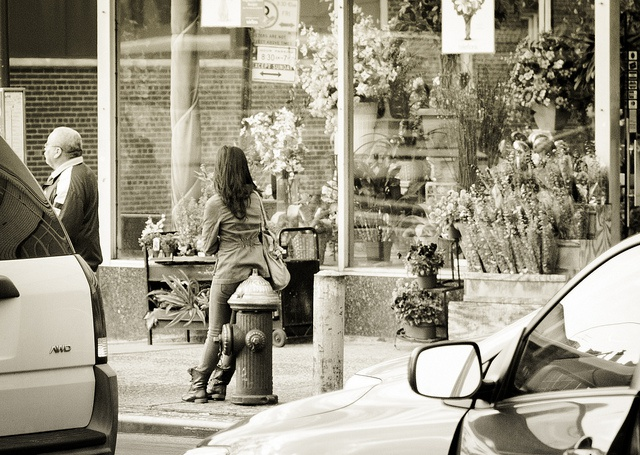Describe the objects in this image and their specific colors. I can see car in black, white, gray, and darkgray tones, car in black, lightgray, and darkgray tones, potted plant in black, beige, tan, lightgray, and gray tones, people in black, darkgray, and gray tones, and fire hydrant in black, ivory, gray, and darkgray tones in this image. 